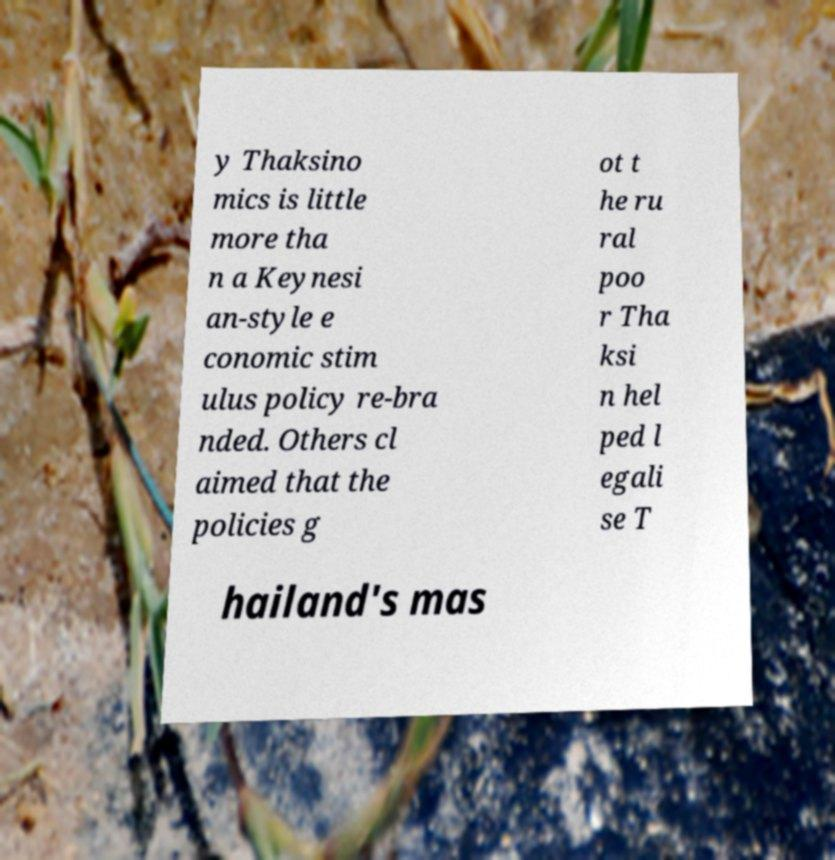Could you extract and type out the text from this image? y Thaksino mics is little more tha n a Keynesi an-style e conomic stim ulus policy re-bra nded. Others cl aimed that the policies g ot t he ru ral poo r Tha ksi n hel ped l egali se T hailand's mas 